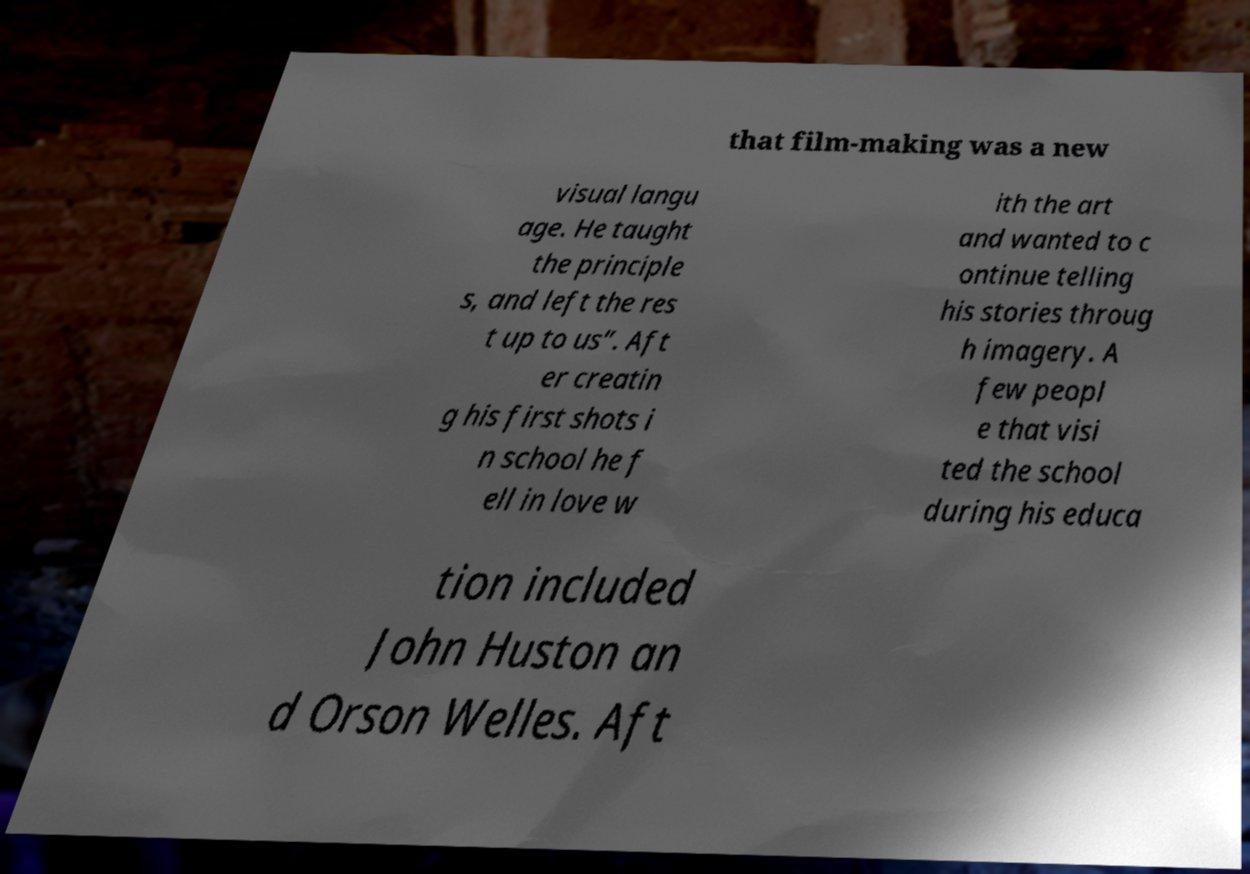Could you extract and type out the text from this image? that film-making was a new visual langu age. He taught the principle s, and left the res t up to us”. Aft er creatin g his first shots i n school he f ell in love w ith the art and wanted to c ontinue telling his stories throug h imagery. A few peopl e that visi ted the school during his educa tion included John Huston an d Orson Welles. Aft 